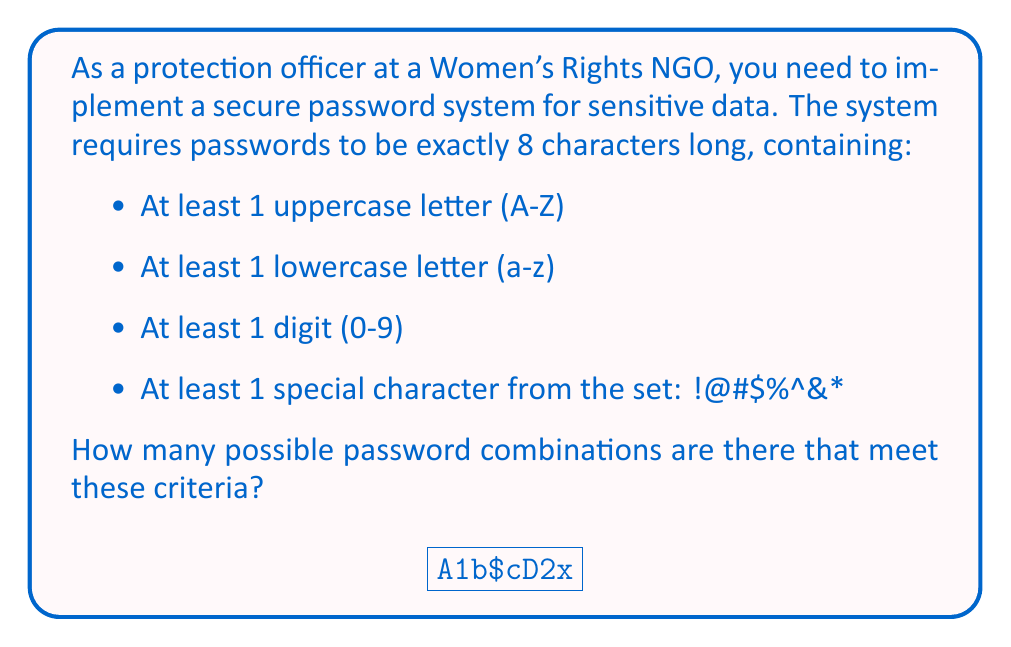Give your solution to this math problem. Let's approach this step-by-step:

1) First, we need to calculate the total number of characters available:
   - 26 uppercase letters
   - 26 lowercase letters
   - 10 digits
   - 8 special characters
   Total: $26 + 26 + 10 + 8 = 70$ characters

2) Now, we need to use the complement rule. We'll calculate the total number of 8-character passwords minus those that don't meet our criteria.

3) Total number of 8-character passwords: $70^8$

4) Now, let's calculate passwords that don't meet the criteria:
   a) No uppercase: $44^8$
   b) No lowercase: $44^8$
   c) No digit: $60^8$
   d) No special character: $62^8$

5) However, if we simply subtract these from the total, we'll have overcounted. We need to add back the passwords that are missing two types of characters, then subtract those missing three, and finally add those missing all four:

   a) Missing two types: $\binom{4}{2} \cdot 34^8$
   b) Missing three types: $\binom{4}{3} \cdot 26^8$
   c) Missing all four types: $\binom{4}{4} \cdot 0^8 = 0$

6) Putting it all together:

   $$ 70^8 - (44^8 + 44^8 + 60^8 + 62^8) + (6 \cdot 34^8) - (4 \cdot 26^8) $$

7) Calculating this gives us the final answer.
Answer: $$5.31699 \times 10^{14}$$ (rounded to 5 significant figures) 